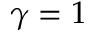Convert formula to latex. <formula><loc_0><loc_0><loc_500><loc_500>\gamma = 1</formula> 